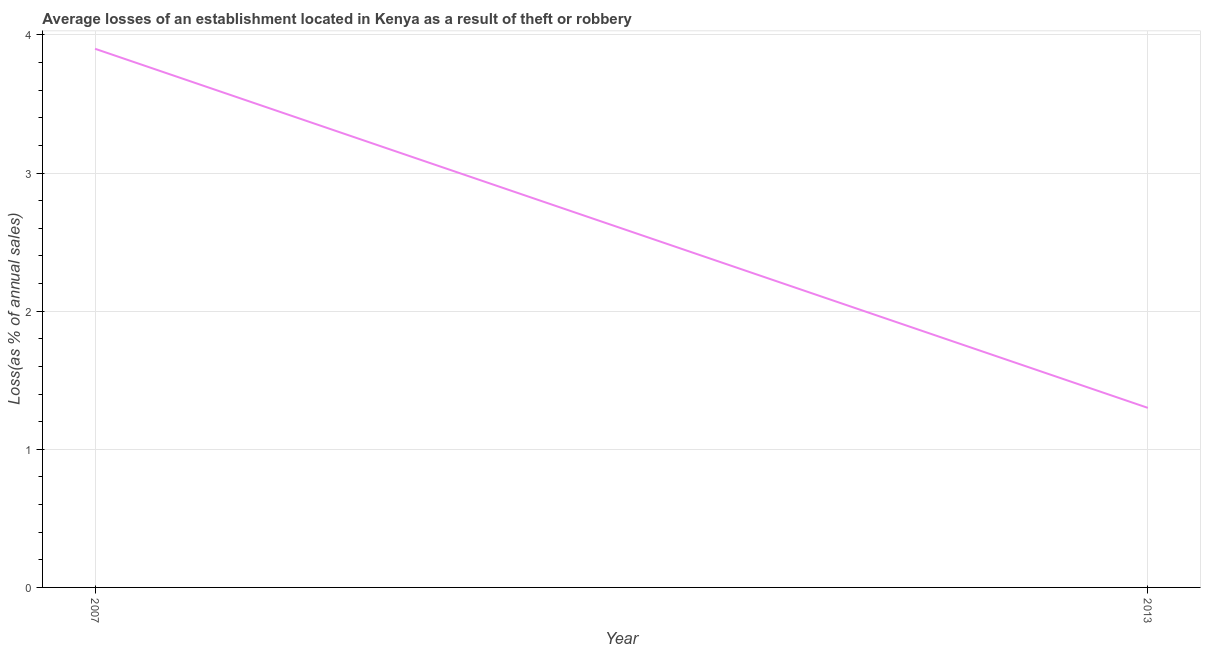What is the difference between the losses due to theft in 2007 and 2013?
Your answer should be compact. 2.6. What is the median losses due to theft?
Your answer should be compact. 2.6. In how many years, is the losses due to theft greater than 1.8 %?
Provide a succinct answer. 1. Is the losses due to theft in 2007 less than that in 2013?
Make the answer very short. No. Does the graph contain any zero values?
Your response must be concise. No. What is the title of the graph?
Make the answer very short. Average losses of an establishment located in Kenya as a result of theft or robbery. What is the label or title of the Y-axis?
Provide a succinct answer. Loss(as % of annual sales). 